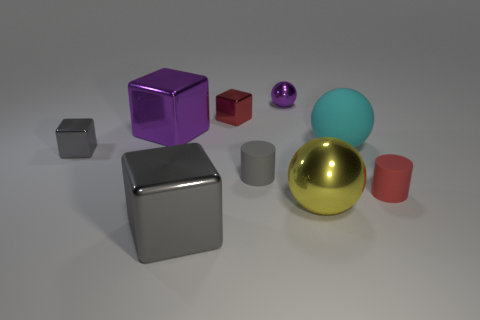There is a tiny metal ball that is behind the large yellow sphere; is it the same color as the big metal block that is behind the red cylinder?
Your answer should be compact. Yes. What number of balls are either large matte things or large metallic objects?
Give a very brief answer. 2. Are there an equal number of large metallic blocks that are left of the cyan thing and big yellow spheres?
Give a very brief answer. No. There is a cube in front of the thing that is left of the large metal cube that is behind the large gray cube; what is it made of?
Give a very brief answer. Metal. What material is the object that is the same color as the small sphere?
Make the answer very short. Metal. How many objects are either small matte objects to the left of the yellow shiny object or large yellow metallic cylinders?
Your answer should be very brief. 1. What number of objects are yellow spheres or rubber objects to the right of the big yellow metallic sphere?
Keep it short and to the point. 3. There is a large ball behind the small gray thing that is left of the big purple object; how many big metallic spheres are right of it?
Keep it short and to the point. 0. What is the material of the cyan ball that is the same size as the purple metallic cube?
Your response must be concise. Rubber. Are there any yellow objects of the same size as the cyan ball?
Keep it short and to the point. Yes. 